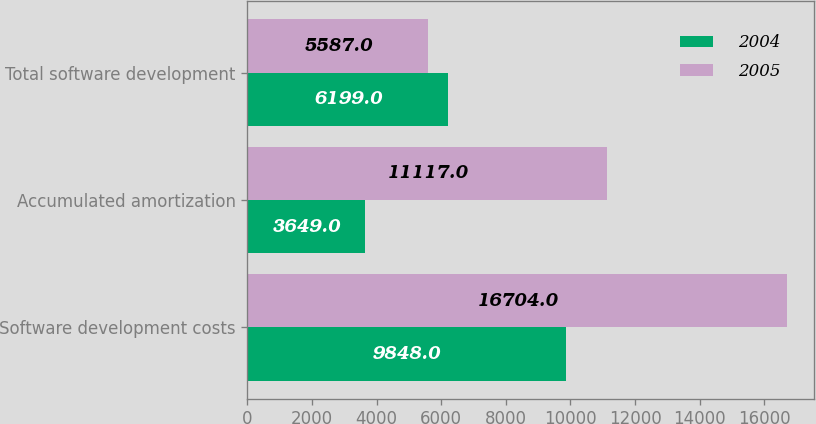Convert chart to OTSL. <chart><loc_0><loc_0><loc_500><loc_500><stacked_bar_chart><ecel><fcel>Software development costs<fcel>Accumulated amortization<fcel>Total software development<nl><fcel>2004<fcel>9848<fcel>3649<fcel>6199<nl><fcel>2005<fcel>16704<fcel>11117<fcel>5587<nl></chart> 